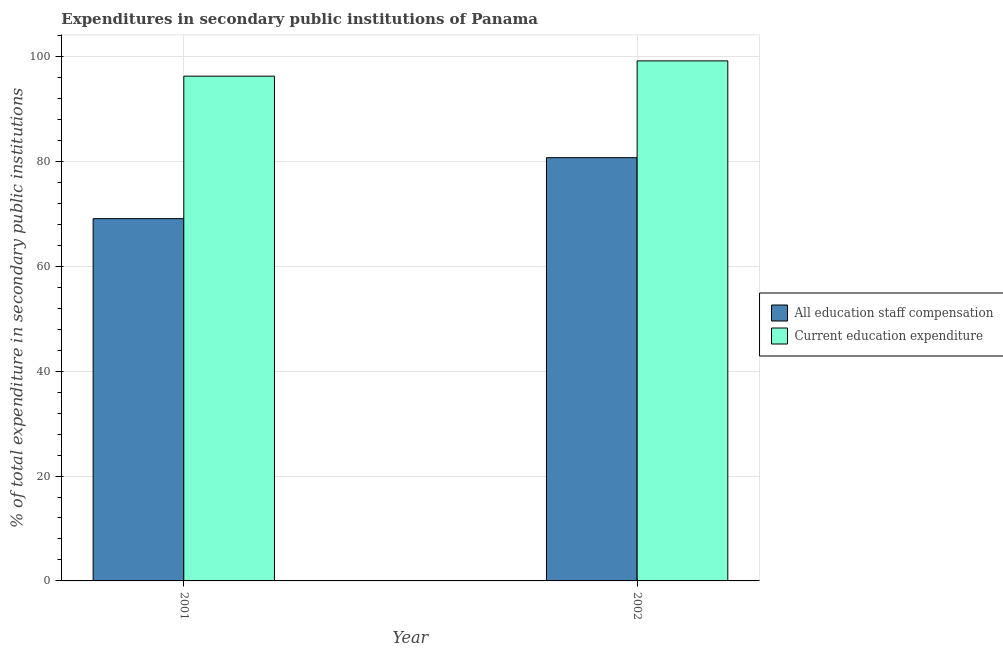Are the number of bars on each tick of the X-axis equal?
Your answer should be compact. Yes. How many bars are there on the 1st tick from the left?
Offer a very short reply. 2. How many bars are there on the 1st tick from the right?
Provide a succinct answer. 2. What is the label of the 2nd group of bars from the left?
Your response must be concise. 2002. In how many cases, is the number of bars for a given year not equal to the number of legend labels?
Your response must be concise. 0. What is the expenditure in education in 2002?
Your answer should be very brief. 99.17. Across all years, what is the maximum expenditure in education?
Ensure brevity in your answer.  99.17. Across all years, what is the minimum expenditure in staff compensation?
Your answer should be compact. 69.09. In which year was the expenditure in education maximum?
Give a very brief answer. 2002. In which year was the expenditure in education minimum?
Provide a short and direct response. 2001. What is the total expenditure in education in the graph?
Provide a short and direct response. 195.43. What is the difference between the expenditure in education in 2001 and that in 2002?
Your answer should be very brief. -2.91. What is the difference between the expenditure in staff compensation in 2001 and the expenditure in education in 2002?
Ensure brevity in your answer.  -11.63. What is the average expenditure in staff compensation per year?
Your answer should be very brief. 74.9. What is the ratio of the expenditure in staff compensation in 2001 to that in 2002?
Offer a very short reply. 0.86. Is the expenditure in staff compensation in 2001 less than that in 2002?
Provide a short and direct response. Yes. In how many years, is the expenditure in education greater than the average expenditure in education taken over all years?
Your response must be concise. 1. What does the 1st bar from the left in 2002 represents?
Give a very brief answer. All education staff compensation. What does the 1st bar from the right in 2002 represents?
Your answer should be compact. Current education expenditure. How many bars are there?
Your answer should be very brief. 4. Are all the bars in the graph horizontal?
Offer a terse response. No. Are the values on the major ticks of Y-axis written in scientific E-notation?
Offer a terse response. No. What is the title of the graph?
Give a very brief answer. Expenditures in secondary public institutions of Panama. Does "2012 US$" appear as one of the legend labels in the graph?
Your answer should be compact. No. What is the label or title of the X-axis?
Provide a succinct answer. Year. What is the label or title of the Y-axis?
Your answer should be very brief. % of total expenditure in secondary public institutions. What is the % of total expenditure in secondary public institutions of All education staff compensation in 2001?
Your response must be concise. 69.09. What is the % of total expenditure in secondary public institutions in Current education expenditure in 2001?
Keep it short and to the point. 96.26. What is the % of total expenditure in secondary public institutions in All education staff compensation in 2002?
Offer a very short reply. 80.71. What is the % of total expenditure in secondary public institutions in Current education expenditure in 2002?
Your answer should be compact. 99.17. Across all years, what is the maximum % of total expenditure in secondary public institutions in All education staff compensation?
Make the answer very short. 80.71. Across all years, what is the maximum % of total expenditure in secondary public institutions of Current education expenditure?
Your answer should be very brief. 99.17. Across all years, what is the minimum % of total expenditure in secondary public institutions in All education staff compensation?
Offer a very short reply. 69.09. Across all years, what is the minimum % of total expenditure in secondary public institutions in Current education expenditure?
Keep it short and to the point. 96.26. What is the total % of total expenditure in secondary public institutions of All education staff compensation in the graph?
Make the answer very short. 149.8. What is the total % of total expenditure in secondary public institutions in Current education expenditure in the graph?
Offer a very short reply. 195.43. What is the difference between the % of total expenditure in secondary public institutions of All education staff compensation in 2001 and that in 2002?
Your answer should be very brief. -11.63. What is the difference between the % of total expenditure in secondary public institutions of Current education expenditure in 2001 and that in 2002?
Make the answer very short. -2.91. What is the difference between the % of total expenditure in secondary public institutions of All education staff compensation in 2001 and the % of total expenditure in secondary public institutions of Current education expenditure in 2002?
Provide a succinct answer. -30.09. What is the average % of total expenditure in secondary public institutions of All education staff compensation per year?
Give a very brief answer. 74.9. What is the average % of total expenditure in secondary public institutions in Current education expenditure per year?
Your answer should be very brief. 97.72. In the year 2001, what is the difference between the % of total expenditure in secondary public institutions of All education staff compensation and % of total expenditure in secondary public institutions of Current education expenditure?
Offer a very short reply. -27.17. In the year 2002, what is the difference between the % of total expenditure in secondary public institutions of All education staff compensation and % of total expenditure in secondary public institutions of Current education expenditure?
Give a very brief answer. -18.46. What is the ratio of the % of total expenditure in secondary public institutions of All education staff compensation in 2001 to that in 2002?
Offer a very short reply. 0.86. What is the ratio of the % of total expenditure in secondary public institutions in Current education expenditure in 2001 to that in 2002?
Your answer should be very brief. 0.97. What is the difference between the highest and the second highest % of total expenditure in secondary public institutions of All education staff compensation?
Your answer should be very brief. 11.63. What is the difference between the highest and the second highest % of total expenditure in secondary public institutions of Current education expenditure?
Ensure brevity in your answer.  2.91. What is the difference between the highest and the lowest % of total expenditure in secondary public institutions of All education staff compensation?
Your response must be concise. 11.63. What is the difference between the highest and the lowest % of total expenditure in secondary public institutions of Current education expenditure?
Keep it short and to the point. 2.91. 